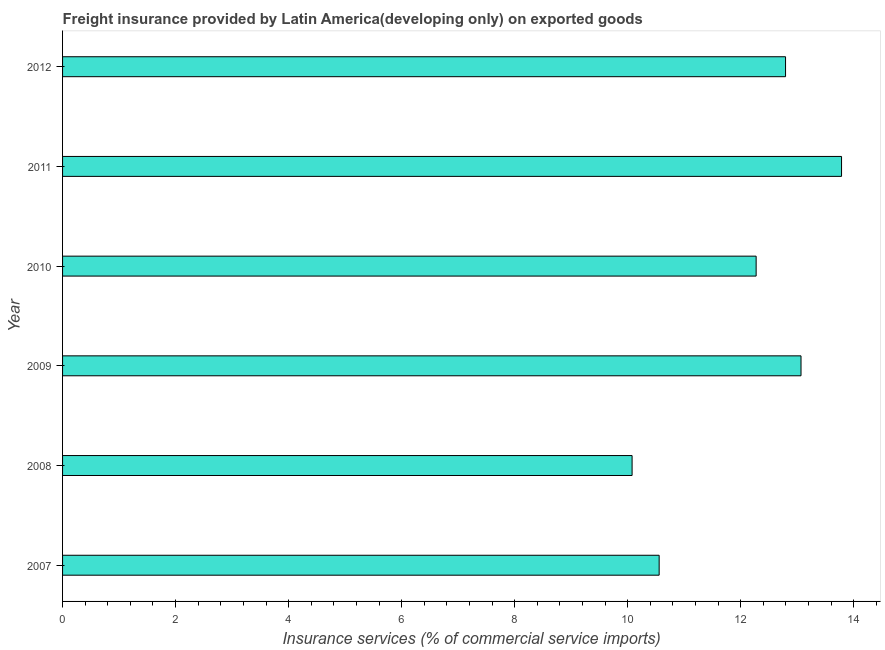Does the graph contain grids?
Give a very brief answer. No. What is the title of the graph?
Provide a short and direct response. Freight insurance provided by Latin America(developing only) on exported goods . What is the label or title of the X-axis?
Your answer should be compact. Insurance services (% of commercial service imports). What is the label or title of the Y-axis?
Give a very brief answer. Year. What is the freight insurance in 2008?
Your answer should be compact. 10.08. Across all years, what is the maximum freight insurance?
Ensure brevity in your answer.  13.79. Across all years, what is the minimum freight insurance?
Give a very brief answer. 10.08. What is the sum of the freight insurance?
Provide a short and direct response. 72.56. What is the difference between the freight insurance in 2009 and 2011?
Your response must be concise. -0.72. What is the average freight insurance per year?
Offer a terse response. 12.09. What is the median freight insurance?
Ensure brevity in your answer.  12.53. In how many years, is the freight insurance greater than 3.6 %?
Give a very brief answer. 6. What is the ratio of the freight insurance in 2007 to that in 2011?
Keep it short and to the point. 0.77. Is the difference between the freight insurance in 2009 and 2010 greater than the difference between any two years?
Give a very brief answer. No. What is the difference between the highest and the second highest freight insurance?
Your response must be concise. 0.72. What is the difference between the highest and the lowest freight insurance?
Make the answer very short. 3.71. How many bars are there?
Make the answer very short. 6. What is the difference between two consecutive major ticks on the X-axis?
Your answer should be very brief. 2. What is the Insurance services (% of commercial service imports) in 2007?
Your answer should be very brief. 10.56. What is the Insurance services (% of commercial service imports) in 2008?
Offer a very short reply. 10.08. What is the Insurance services (% of commercial service imports) of 2009?
Ensure brevity in your answer.  13.07. What is the Insurance services (% of commercial service imports) in 2010?
Keep it short and to the point. 12.27. What is the Insurance services (% of commercial service imports) of 2011?
Provide a succinct answer. 13.79. What is the Insurance services (% of commercial service imports) of 2012?
Your response must be concise. 12.79. What is the difference between the Insurance services (% of commercial service imports) in 2007 and 2008?
Make the answer very short. 0.48. What is the difference between the Insurance services (% of commercial service imports) in 2007 and 2009?
Make the answer very short. -2.51. What is the difference between the Insurance services (% of commercial service imports) in 2007 and 2010?
Offer a very short reply. -1.72. What is the difference between the Insurance services (% of commercial service imports) in 2007 and 2011?
Offer a very short reply. -3.23. What is the difference between the Insurance services (% of commercial service imports) in 2007 and 2012?
Ensure brevity in your answer.  -2.24. What is the difference between the Insurance services (% of commercial service imports) in 2008 and 2009?
Offer a terse response. -2.99. What is the difference between the Insurance services (% of commercial service imports) in 2008 and 2010?
Your response must be concise. -2.2. What is the difference between the Insurance services (% of commercial service imports) in 2008 and 2011?
Make the answer very short. -3.71. What is the difference between the Insurance services (% of commercial service imports) in 2008 and 2012?
Your answer should be compact. -2.72. What is the difference between the Insurance services (% of commercial service imports) in 2009 and 2010?
Provide a short and direct response. 0.79. What is the difference between the Insurance services (% of commercial service imports) in 2009 and 2011?
Provide a short and direct response. -0.72. What is the difference between the Insurance services (% of commercial service imports) in 2009 and 2012?
Give a very brief answer. 0.27. What is the difference between the Insurance services (% of commercial service imports) in 2010 and 2011?
Offer a terse response. -1.51. What is the difference between the Insurance services (% of commercial service imports) in 2010 and 2012?
Provide a short and direct response. -0.52. What is the difference between the Insurance services (% of commercial service imports) in 2011 and 2012?
Keep it short and to the point. 0.99. What is the ratio of the Insurance services (% of commercial service imports) in 2007 to that in 2008?
Ensure brevity in your answer.  1.05. What is the ratio of the Insurance services (% of commercial service imports) in 2007 to that in 2009?
Ensure brevity in your answer.  0.81. What is the ratio of the Insurance services (% of commercial service imports) in 2007 to that in 2010?
Provide a succinct answer. 0.86. What is the ratio of the Insurance services (% of commercial service imports) in 2007 to that in 2011?
Give a very brief answer. 0.77. What is the ratio of the Insurance services (% of commercial service imports) in 2007 to that in 2012?
Offer a very short reply. 0.82. What is the ratio of the Insurance services (% of commercial service imports) in 2008 to that in 2009?
Make the answer very short. 0.77. What is the ratio of the Insurance services (% of commercial service imports) in 2008 to that in 2010?
Provide a succinct answer. 0.82. What is the ratio of the Insurance services (% of commercial service imports) in 2008 to that in 2011?
Keep it short and to the point. 0.73. What is the ratio of the Insurance services (% of commercial service imports) in 2008 to that in 2012?
Ensure brevity in your answer.  0.79. What is the ratio of the Insurance services (% of commercial service imports) in 2009 to that in 2010?
Offer a terse response. 1.06. What is the ratio of the Insurance services (% of commercial service imports) in 2009 to that in 2011?
Provide a succinct answer. 0.95. What is the ratio of the Insurance services (% of commercial service imports) in 2009 to that in 2012?
Your answer should be very brief. 1.02. What is the ratio of the Insurance services (% of commercial service imports) in 2010 to that in 2011?
Give a very brief answer. 0.89. What is the ratio of the Insurance services (% of commercial service imports) in 2010 to that in 2012?
Ensure brevity in your answer.  0.96. What is the ratio of the Insurance services (% of commercial service imports) in 2011 to that in 2012?
Your answer should be compact. 1.08. 